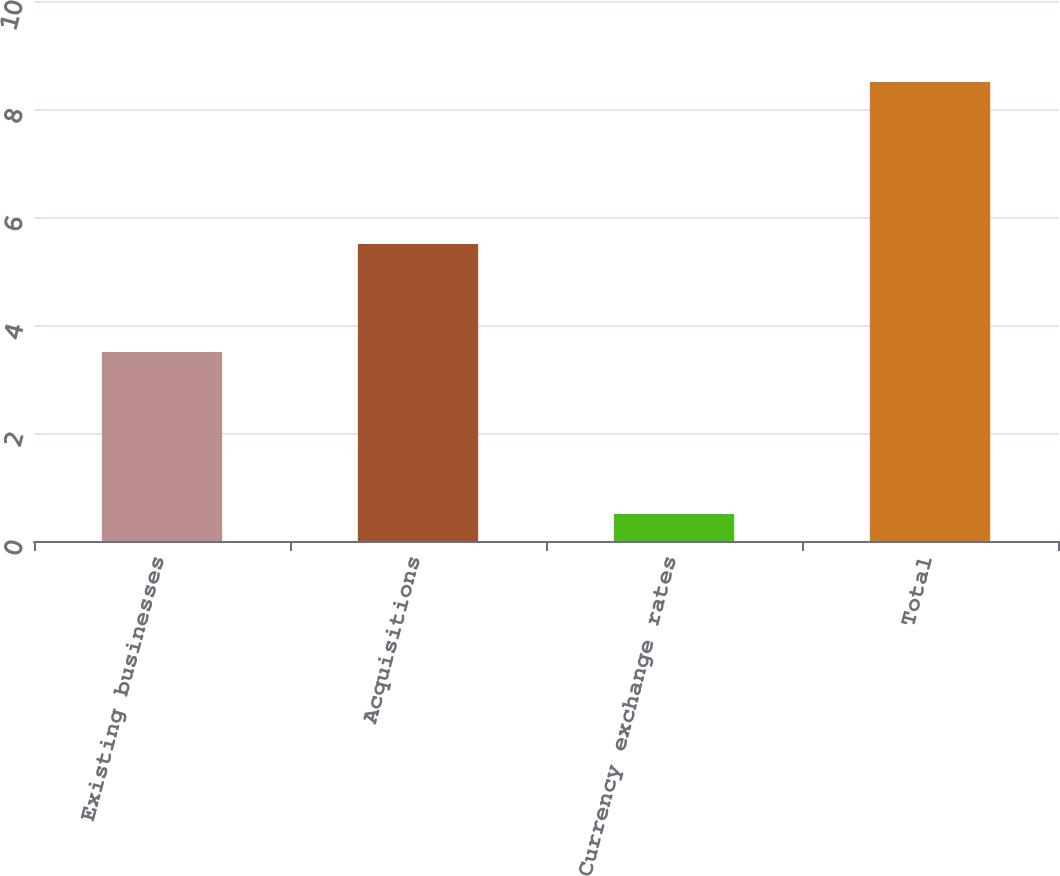Convert chart. <chart><loc_0><loc_0><loc_500><loc_500><bar_chart><fcel>Existing businesses<fcel>Acquisitions<fcel>Currency exchange rates<fcel>Total<nl><fcel>3.5<fcel>5.5<fcel>0.5<fcel>8.5<nl></chart> 